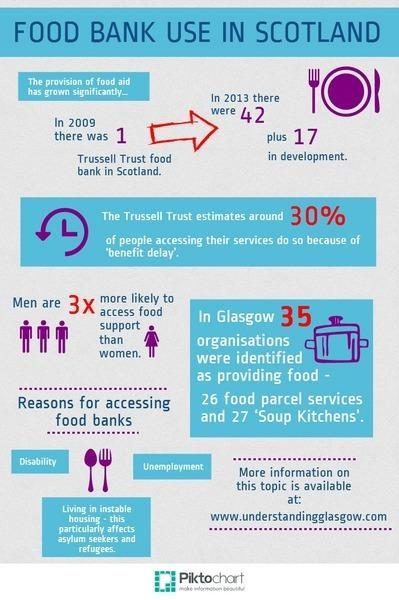How many images of women are shown in the infographic?
Answer the question with a short phrase. 1 Which is the second reason listed to show the necessity for depending on food banks? Unemployment How many reasons are listed to show the necessity for depending on food banks? 3 